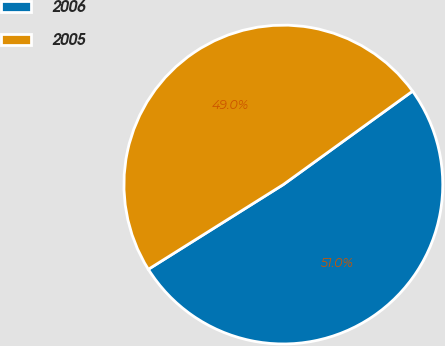Convert chart. <chart><loc_0><loc_0><loc_500><loc_500><pie_chart><fcel>2006<fcel>2005<nl><fcel>51.04%<fcel>48.96%<nl></chart> 